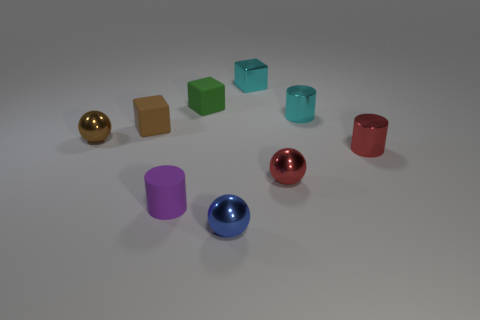The rubber cylinder is what color?
Provide a short and direct response. Purple. Do the small matte thing in front of the brown metal thing and the brown metal thing have the same shape?
Ensure brevity in your answer.  No. There is a cyan object that is behind the rubber block on the right side of the small matte thing in front of the tiny brown cube; what is its shape?
Offer a terse response. Cube. There is a cube right of the tiny blue metallic ball; what is its material?
Make the answer very short. Metal. The rubber cylinder that is the same size as the red metal sphere is what color?
Offer a terse response. Purple. Do the brown cube and the cyan shiny cylinder have the same size?
Give a very brief answer. Yes. Is the number of brown spheres to the left of the small matte cylinder greater than the number of blue shiny spheres that are in front of the blue metal ball?
Give a very brief answer. Yes. How many other things are there of the same size as the brown matte thing?
Your response must be concise. 8. There is a tiny sphere in front of the red ball; is its color the same as the matte cylinder?
Provide a short and direct response. No. Is the number of metal objects that are on the left side of the blue object greater than the number of tiny blue metallic cylinders?
Ensure brevity in your answer.  Yes. 